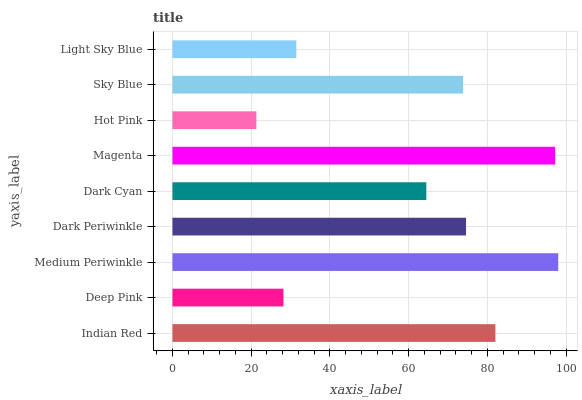Is Hot Pink the minimum?
Answer yes or no. Yes. Is Medium Periwinkle the maximum?
Answer yes or no. Yes. Is Deep Pink the minimum?
Answer yes or no. No. Is Deep Pink the maximum?
Answer yes or no. No. Is Indian Red greater than Deep Pink?
Answer yes or no. Yes. Is Deep Pink less than Indian Red?
Answer yes or no. Yes. Is Deep Pink greater than Indian Red?
Answer yes or no. No. Is Indian Red less than Deep Pink?
Answer yes or no. No. Is Sky Blue the high median?
Answer yes or no. Yes. Is Sky Blue the low median?
Answer yes or no. Yes. Is Medium Periwinkle the high median?
Answer yes or no. No. Is Medium Periwinkle the low median?
Answer yes or no. No. 